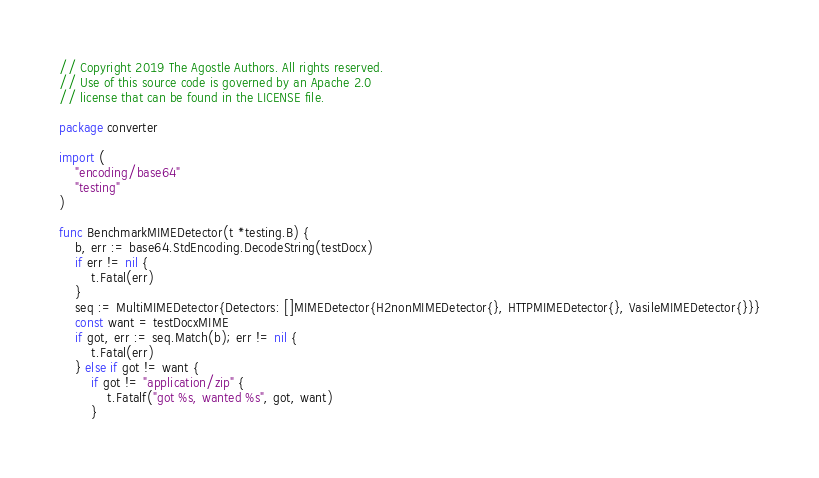<code> <loc_0><loc_0><loc_500><loc_500><_Go_>// Copyright 2019 The Agostle Authors. All rights reserved.
// Use of this source code is governed by an Apache 2.0
// license that can be found in the LICENSE file.

package converter

import (
	"encoding/base64"
	"testing"
)

func BenchmarkMIMEDetector(t *testing.B) {
	b, err := base64.StdEncoding.DecodeString(testDocx)
	if err != nil {
		t.Fatal(err)
	}
	seq := MultiMIMEDetector{Detectors: []MIMEDetector{H2nonMIMEDetector{}, HTTPMIMEDetector{}, VasileMIMEDetector{}}}
	const want = testDocxMIME
	if got, err := seq.Match(b); err != nil {
		t.Fatal(err)
	} else if got != want {
		if got != "application/zip" {
			t.Fatalf("got %s, wanted %s", got, want)
		}</code> 